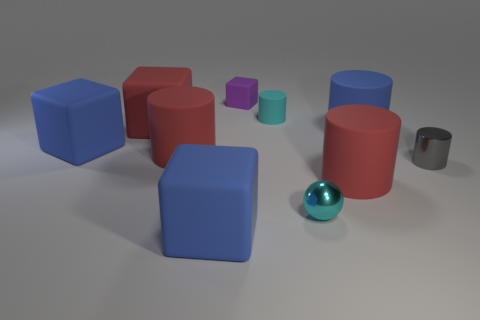Is there a large red cylinder that has the same material as the small sphere?
Ensure brevity in your answer.  No. Does the large blue cylinder have the same material as the tiny sphere?
Give a very brief answer. No. What number of cylinders are gray metallic objects or big green matte things?
Offer a very short reply. 1. There is a small cylinder that is made of the same material as the tiny ball; what color is it?
Provide a succinct answer. Gray. Is the number of small cubes less than the number of small yellow matte cubes?
Your response must be concise. No. There is a metallic thing right of the tiny metallic ball; is it the same shape as the small object that is in front of the metallic cylinder?
Give a very brief answer. No. How many objects are gray cylinders or big red shiny blocks?
Keep it short and to the point. 1. What color is the metal ball that is the same size as the gray metal cylinder?
Provide a succinct answer. Cyan. How many blue cylinders are in front of the large red matte cylinder on the left side of the cyan metallic sphere?
Provide a short and direct response. 0. What number of large blue rubber objects are behind the gray shiny cylinder and on the left side of the purple matte cube?
Your response must be concise. 1. 